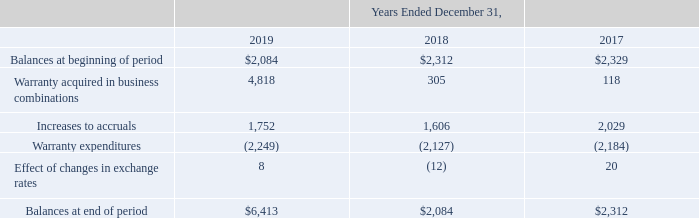ADVANCED ENERGY INDUSTRIES, INC. NOTES TO CONSOLIDATED FINANCIAL STATEMENTS – (continued) (in thousands, except per share amounts)
NOTE 15. WARRANTIES
Provisions of our sales agreements include customary product warranties, ranging from 12 months to 24 months following installation. The estimated cost of our warranty obligation is recorded when revenue is recognized and is based upon our historical experience by product, configuration and geographic region.
Our estimated warranty obligation is included in Other accrued expenses in our Consolidated Balance Sheets. Changes in our product warranty obligation are as follows:
How does the company record the estimated cost of warranty obligation? When revenue is recognized and is based upon our historical experience by product, configuration and geographic region. What are the years included in the table for Changes in our product warranty obligation 2019, 2018, 2017. What was the balance at the beginning of period in 2017?
Answer scale should be: thousand. $2,329. What was the change in warranty acquired in business combinations between 2018 and 2019?
Answer scale should be: thousand. 4,818-305
Answer: 4513. What was the Increases to accruals between 2017 and 2018?
Answer scale should be: thousand. 1,606-2,029
Answer: -423. What was the percentage change in balances at end of period between 2018 and 2019?
Answer scale should be: percent. ($6,413-$2,084)/$2,084
Answer: 207.73. 